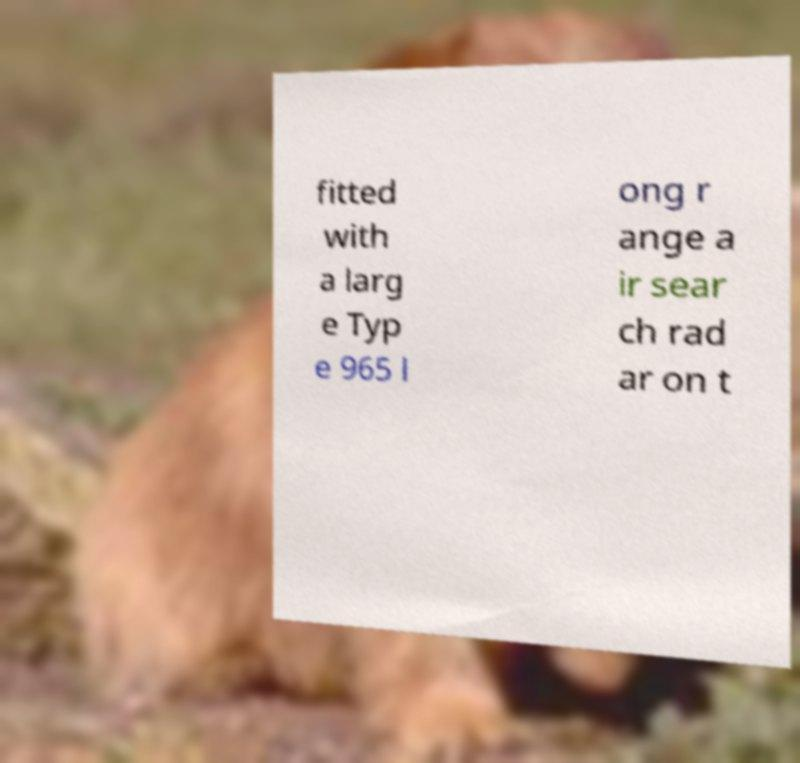Could you assist in decoding the text presented in this image and type it out clearly? fitted with a larg e Typ e 965 l ong r ange a ir sear ch rad ar on t 